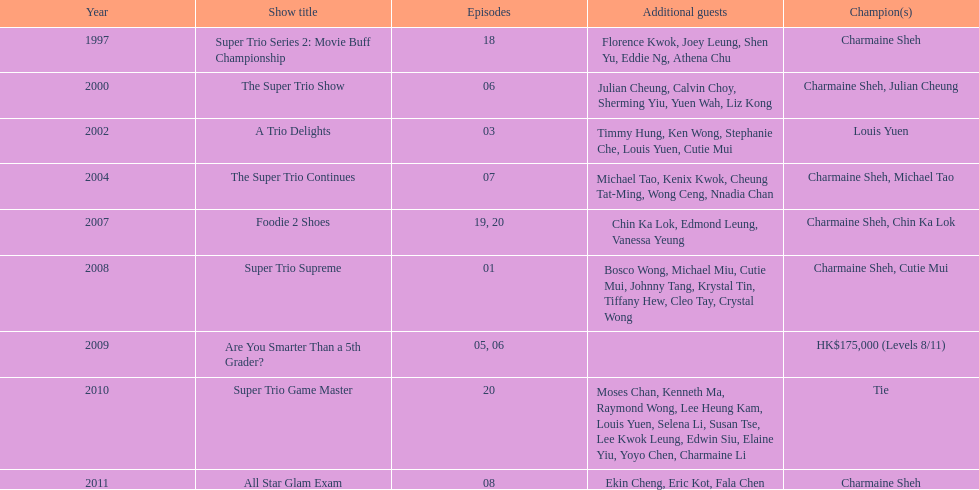What is the number of tv shows that charmaine sheh has appeared on? 9. 